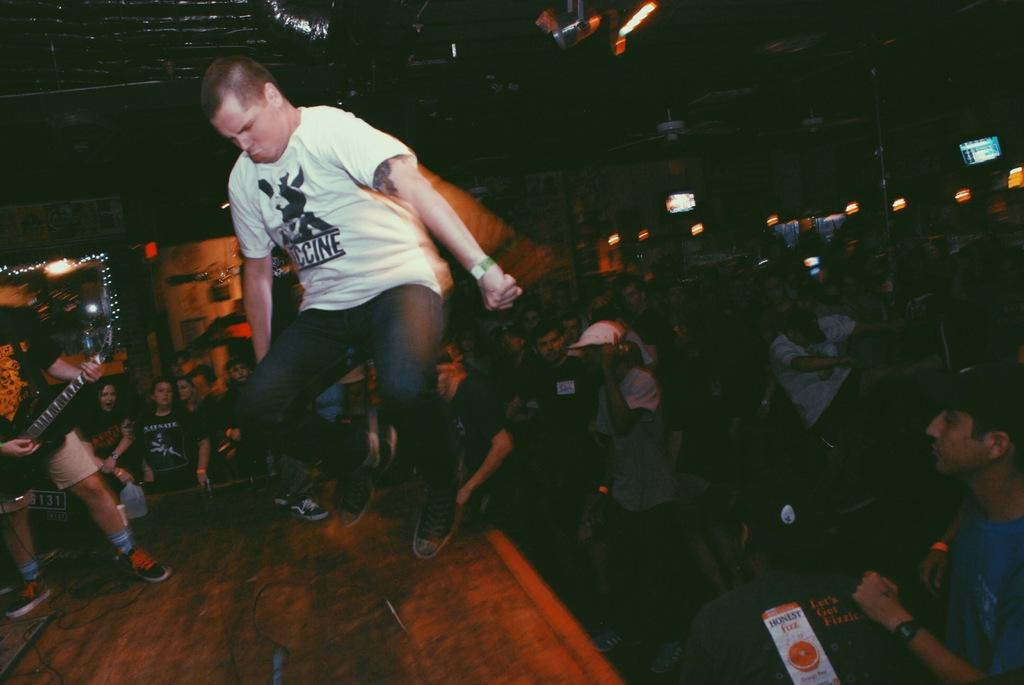What is the person in the image holding? The person is holding a musical instrument in the image. What is the position of the person holding the musical instrument? The person appears to be in the air. What can be seen in the background of the image? There are people and lights visible in the background of the image. What type of cherry is being used as a mute for the musical instrument in the image? There is no cherry present in the image, nor is it being used as a mute for the musical instrument. 